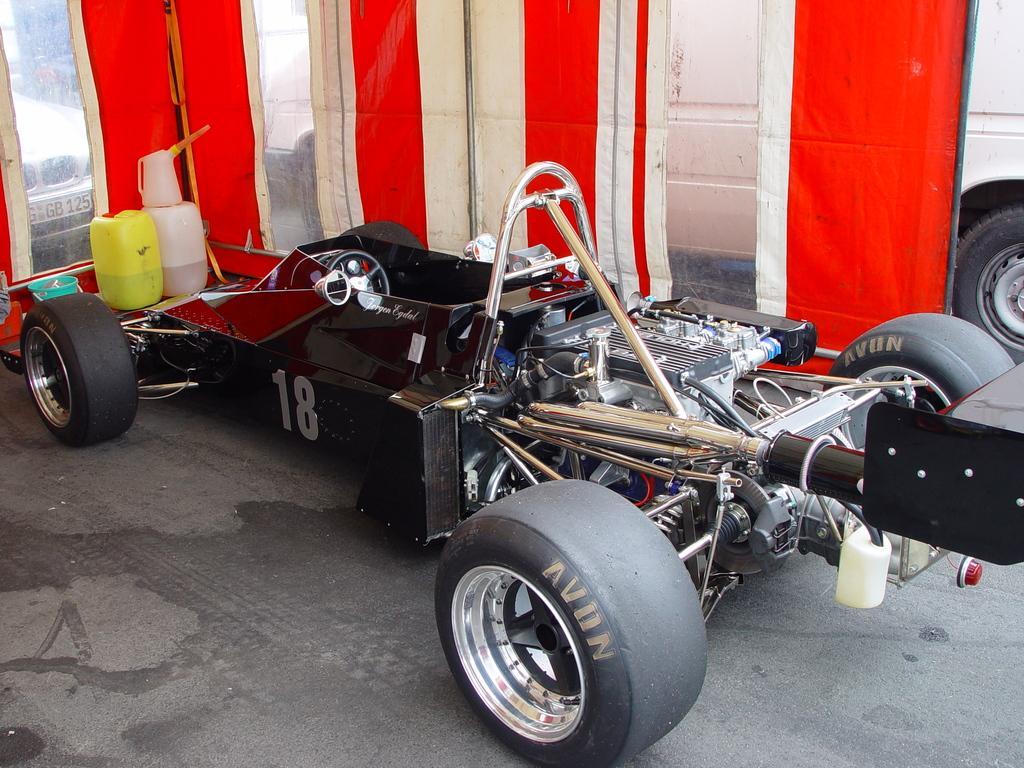In one or two sentences, can you explain what this image depicts? In this picture there is a vehicle in the foreground and there is text on the wheels and there are objects and there is a bucket and there is a sheet. Behind the sheet there are vehicles. At the bottom there is a road. 